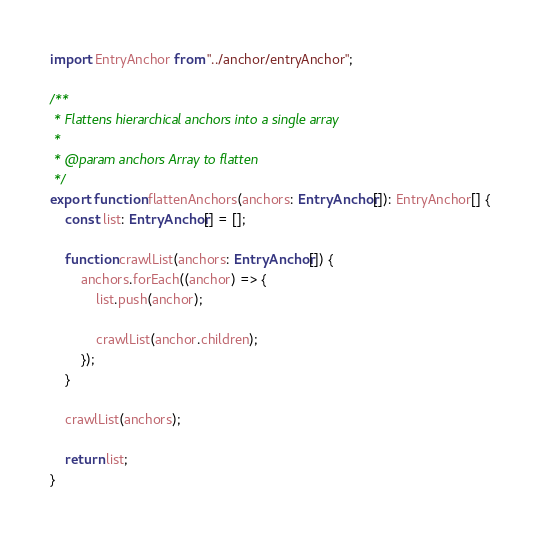Convert code to text. <code><loc_0><loc_0><loc_500><loc_500><_TypeScript_>import EntryAnchor from "../anchor/entryAnchor";

/**
 * Flattens hierarchical anchors into a single array
 *
 * @param anchors Array to flatten
 */
export function flattenAnchors(anchors: EntryAnchor[]): EntryAnchor[] {
    const list: EntryAnchor[] = [];

    function crawlList(anchors: EntryAnchor[]) {
        anchors.forEach((anchor) => {
            list.push(anchor);

            crawlList(anchor.children);
        });
    }

    crawlList(anchors);

    return list;
}
</code> 